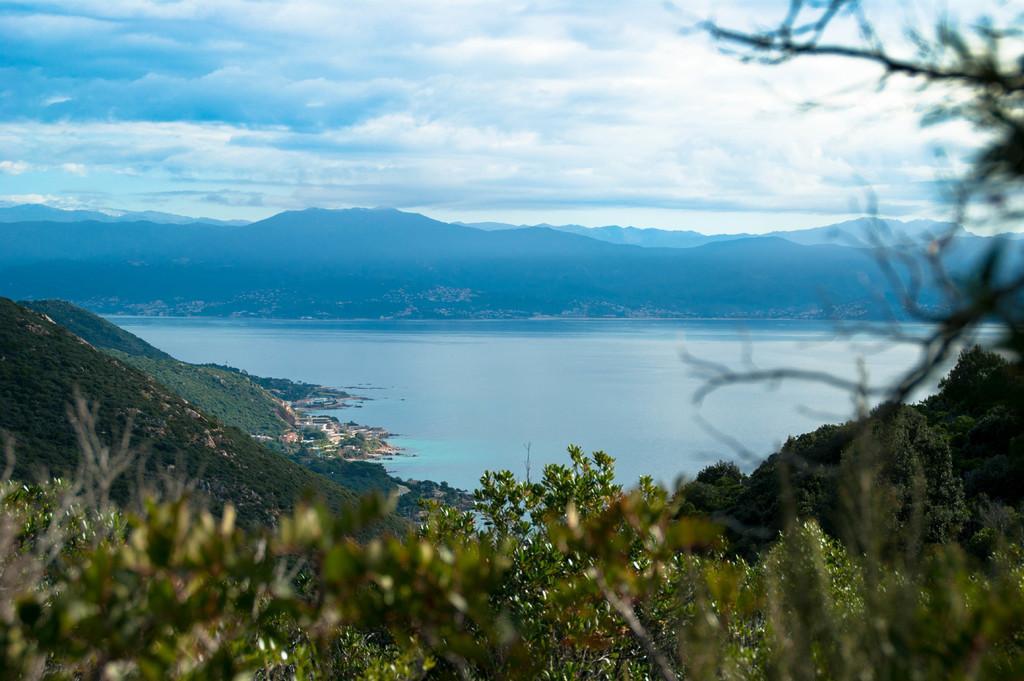Could you give a brief overview of what you see in this image? In this picture we can see a few plants from left to right. There is water. We can see a few mountains in the background. Sky is cloudy. 